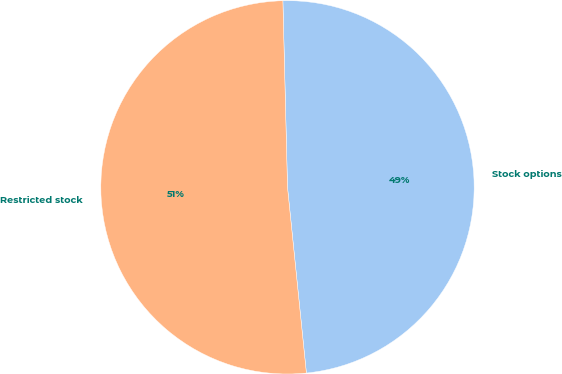Convert chart to OTSL. <chart><loc_0><loc_0><loc_500><loc_500><pie_chart><fcel>Stock options<fcel>Restricted stock<nl><fcel>48.78%<fcel>51.22%<nl></chart> 